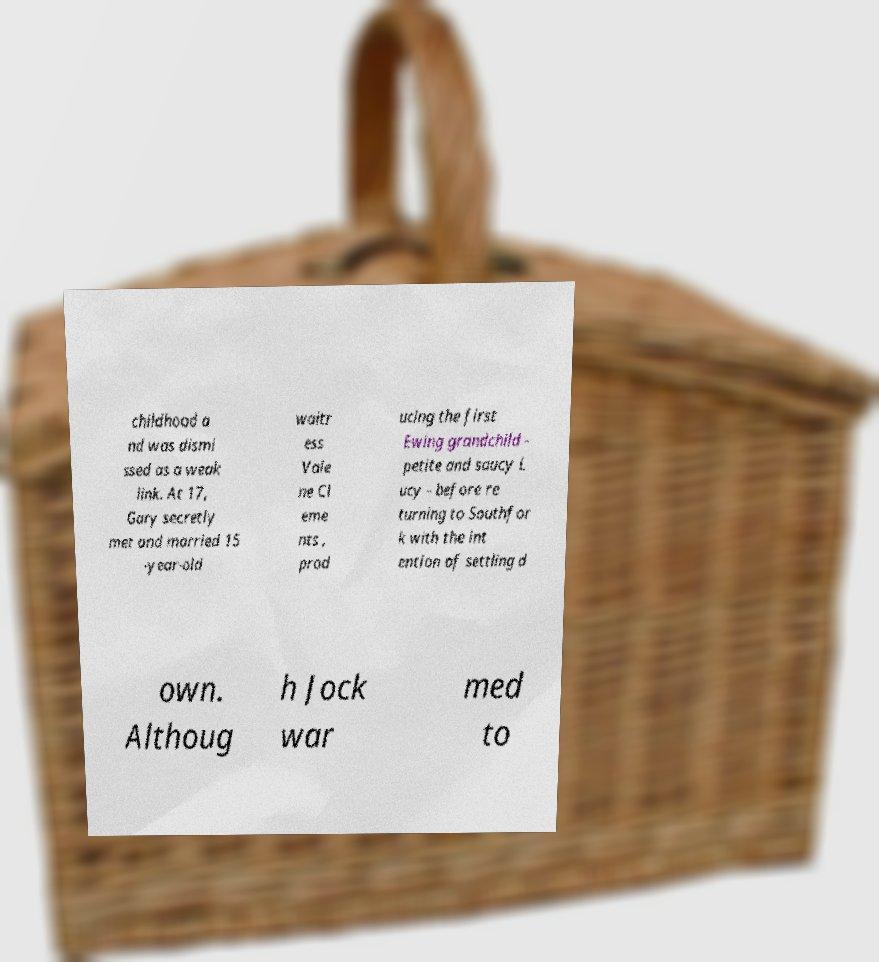Can you read and provide the text displayed in the image?This photo seems to have some interesting text. Can you extract and type it out for me? childhood a nd was dismi ssed as a weak link. At 17, Gary secretly met and married 15 -year-old waitr ess Vale ne Cl eme nts , prod ucing the first Ewing grandchild - petite and saucy L ucy - before re turning to Southfor k with the int ention of settling d own. Althoug h Jock war med to 